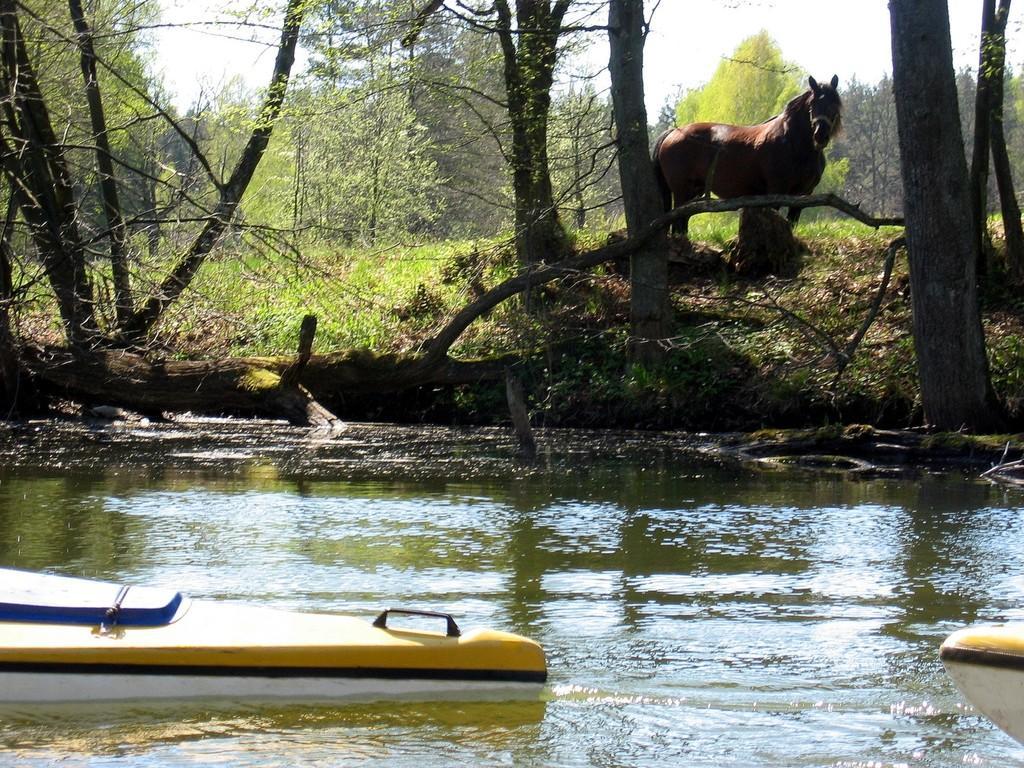In one or two sentences, can you explain what this image depicts? In this image, we can see a horse. We can see some water. There are boats sailing on water. We can see some grass, trees and plants. We can also see the sky. 